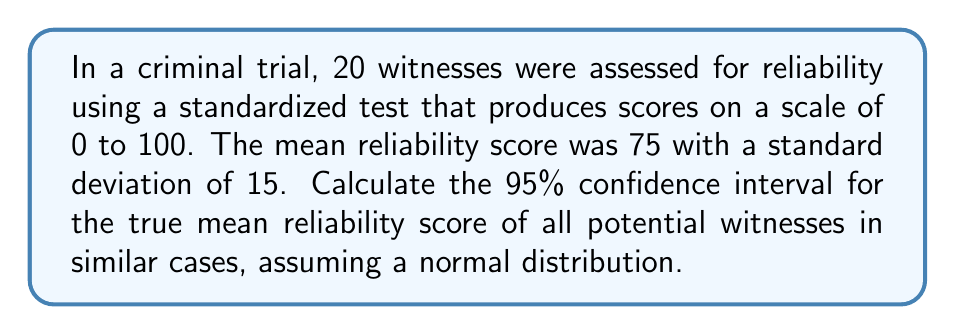Can you solve this math problem? To calculate the 95% confidence interval, we'll follow these steps:

1. Identify the known values:
   - Sample size (n) = 20
   - Sample mean (x̄) = 75
   - Sample standard deviation (s) = 15
   - Confidence level = 95% (α = 0.05)

2. Determine the critical value (t-score) for a 95% confidence interval with 19 degrees of freedom (df = n - 1 = 19):
   t₀.₀₂₅,₁₉ ≈ 2.093 (from t-distribution table)

3. Calculate the standard error of the mean (SEM):
   $$ SEM = \frac{s}{\sqrt{n}} = \frac{15}{\sqrt{20}} = 3.354 $$

4. Compute the margin of error:
   $$ ME = t_{0.025,19} \times SEM = 2.093 \times 3.354 = 7.020 $$

5. Calculate the confidence interval:
   Lower bound: $$ 75 - 7.020 = 67.980 $$
   Upper bound: $$ 75 + 7.020 = 82.020 $$

Therefore, the 95% confidence interval for the true mean reliability score is (67.980, 82.020).
Answer: (67.980, 82.020) 